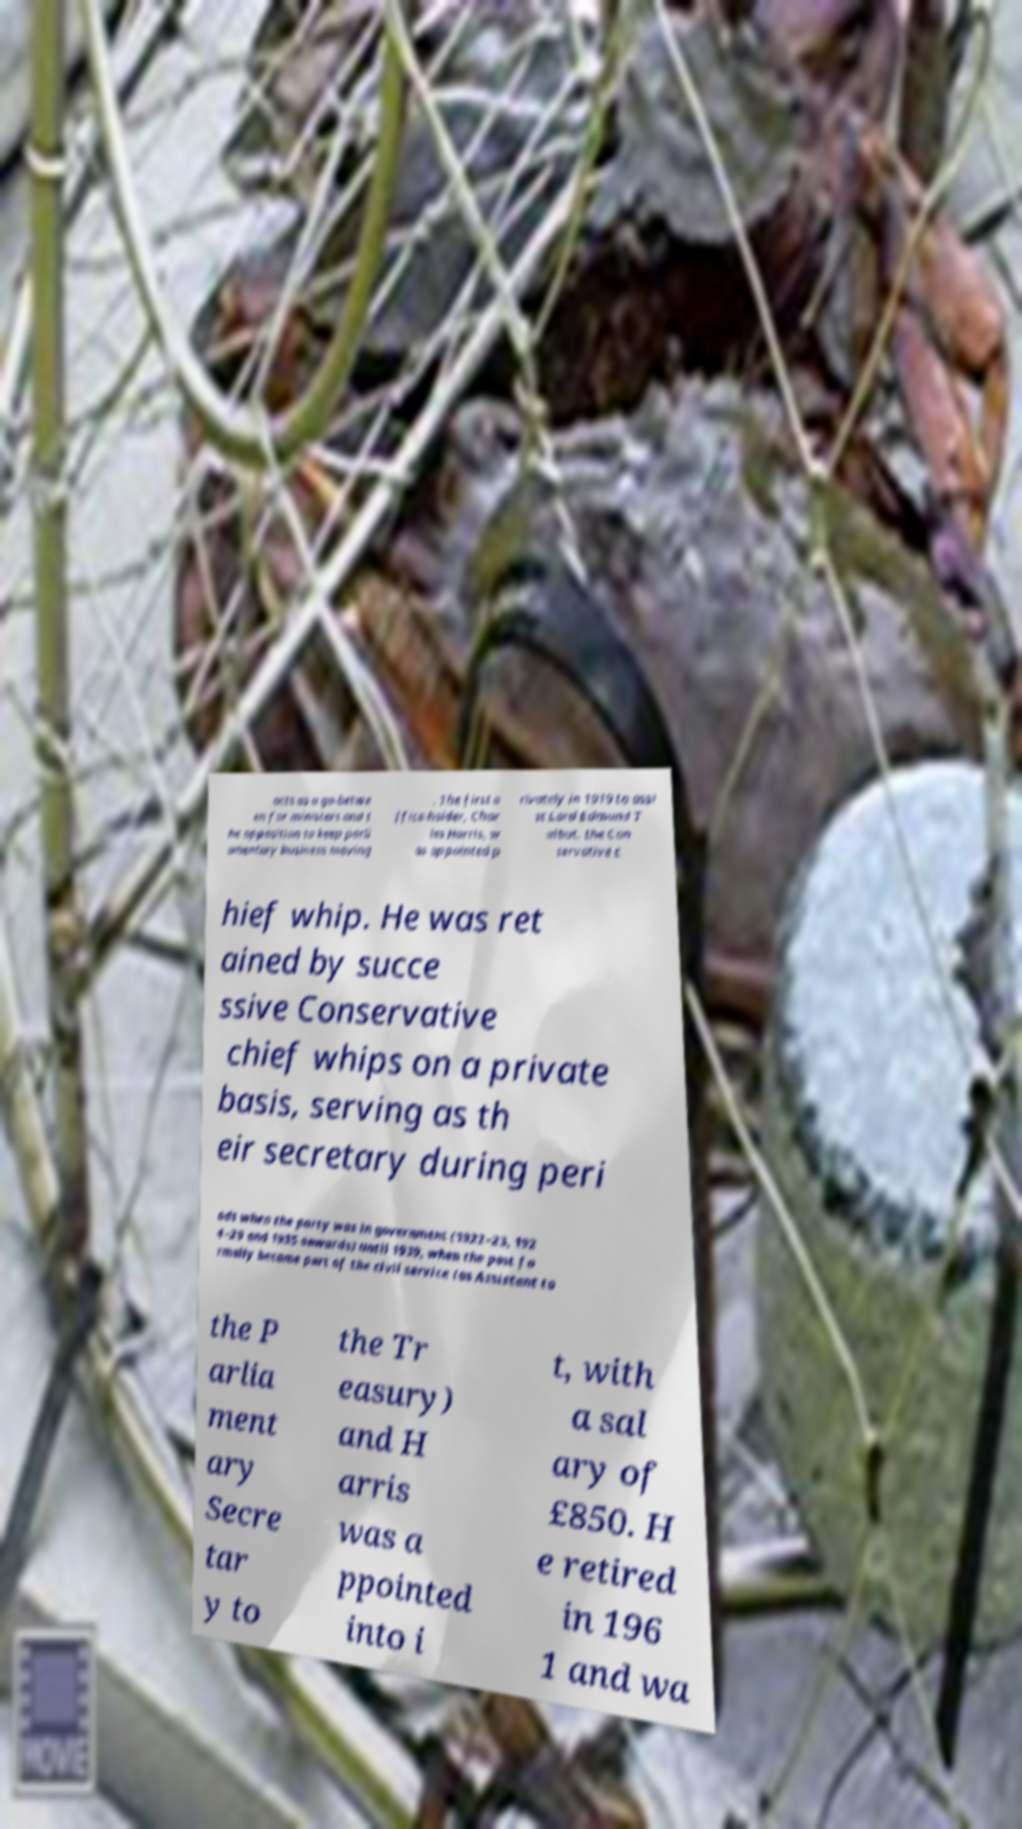Please identify and transcribe the text found in this image. acts as a go-betwe en for ministers and t he opposition to keep parli amentary business moving . The first o ffice-holder, Char les Harris, w as appointed p rivately in 1919 to assi st Lord Edmund T albot, the Con servative c hief whip. He was ret ained by succe ssive Conservative chief whips on a private basis, serving as th eir secretary during peri ods when the party was in government (1922–23, 192 4–29 and 1935 onwards) until 1939, when the post fo rmally became part of the civil service (as Assistant to the P arlia ment ary Secre tar y to the Tr easury) and H arris was a ppointed into i t, with a sal ary of £850. H e retired in 196 1 and wa 